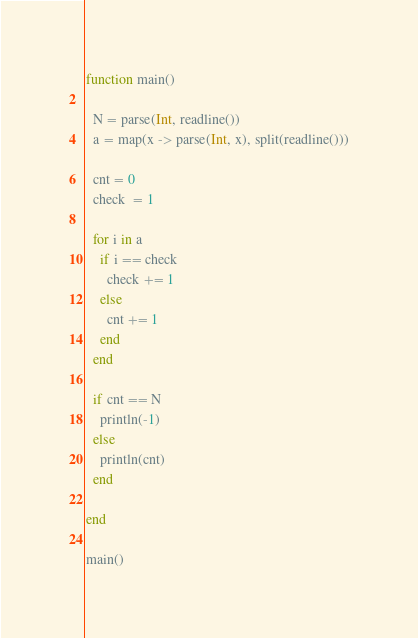<code> <loc_0><loc_0><loc_500><loc_500><_Julia_>function main()
  
  N = parse(Int, readline())
  a = map(x -> parse(Int, x), split(readline()))
  
  cnt = 0
  check  = 1
  
  for i in a
    if i == check
      check += 1
    else
      cnt += 1
    end
  end
  
  if cnt == N
    println(-1)
  else
    println(cnt)
  end
  
end

main()</code> 